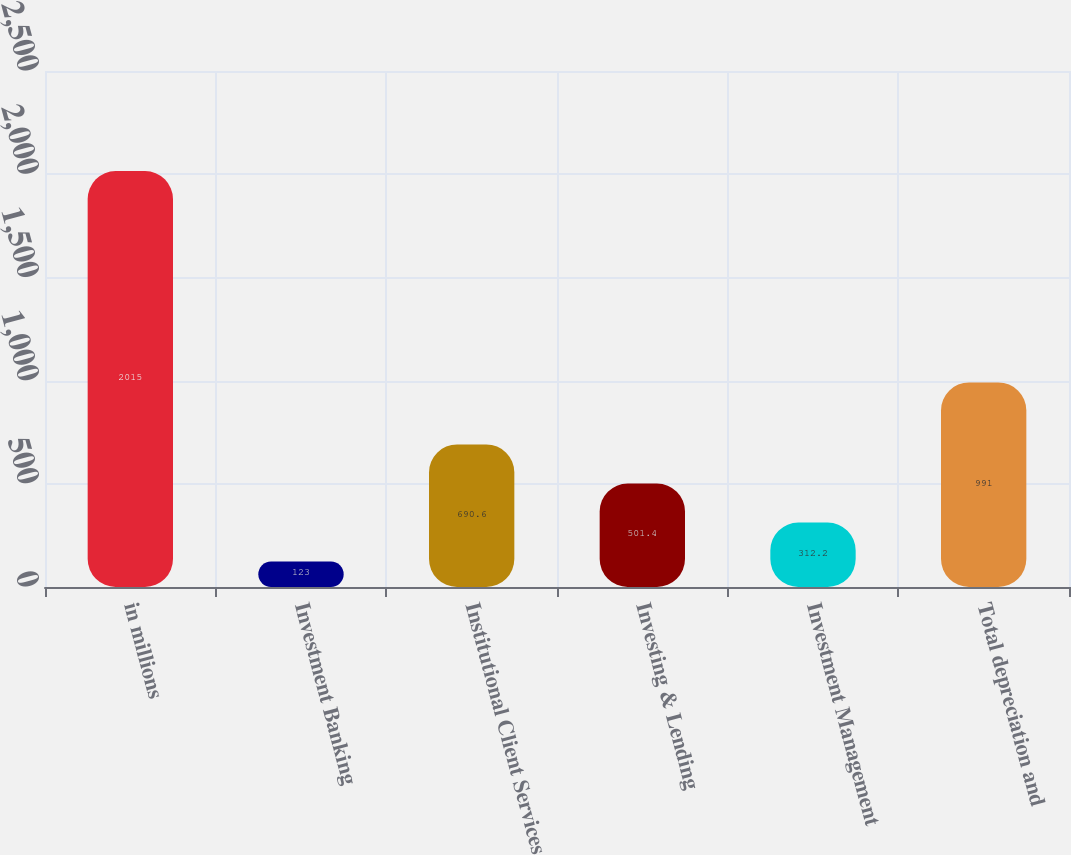<chart> <loc_0><loc_0><loc_500><loc_500><bar_chart><fcel>in millions<fcel>Investment Banking<fcel>Institutional Client Services<fcel>Investing & Lending<fcel>Investment Management<fcel>Total depreciation and<nl><fcel>2015<fcel>123<fcel>690.6<fcel>501.4<fcel>312.2<fcel>991<nl></chart> 